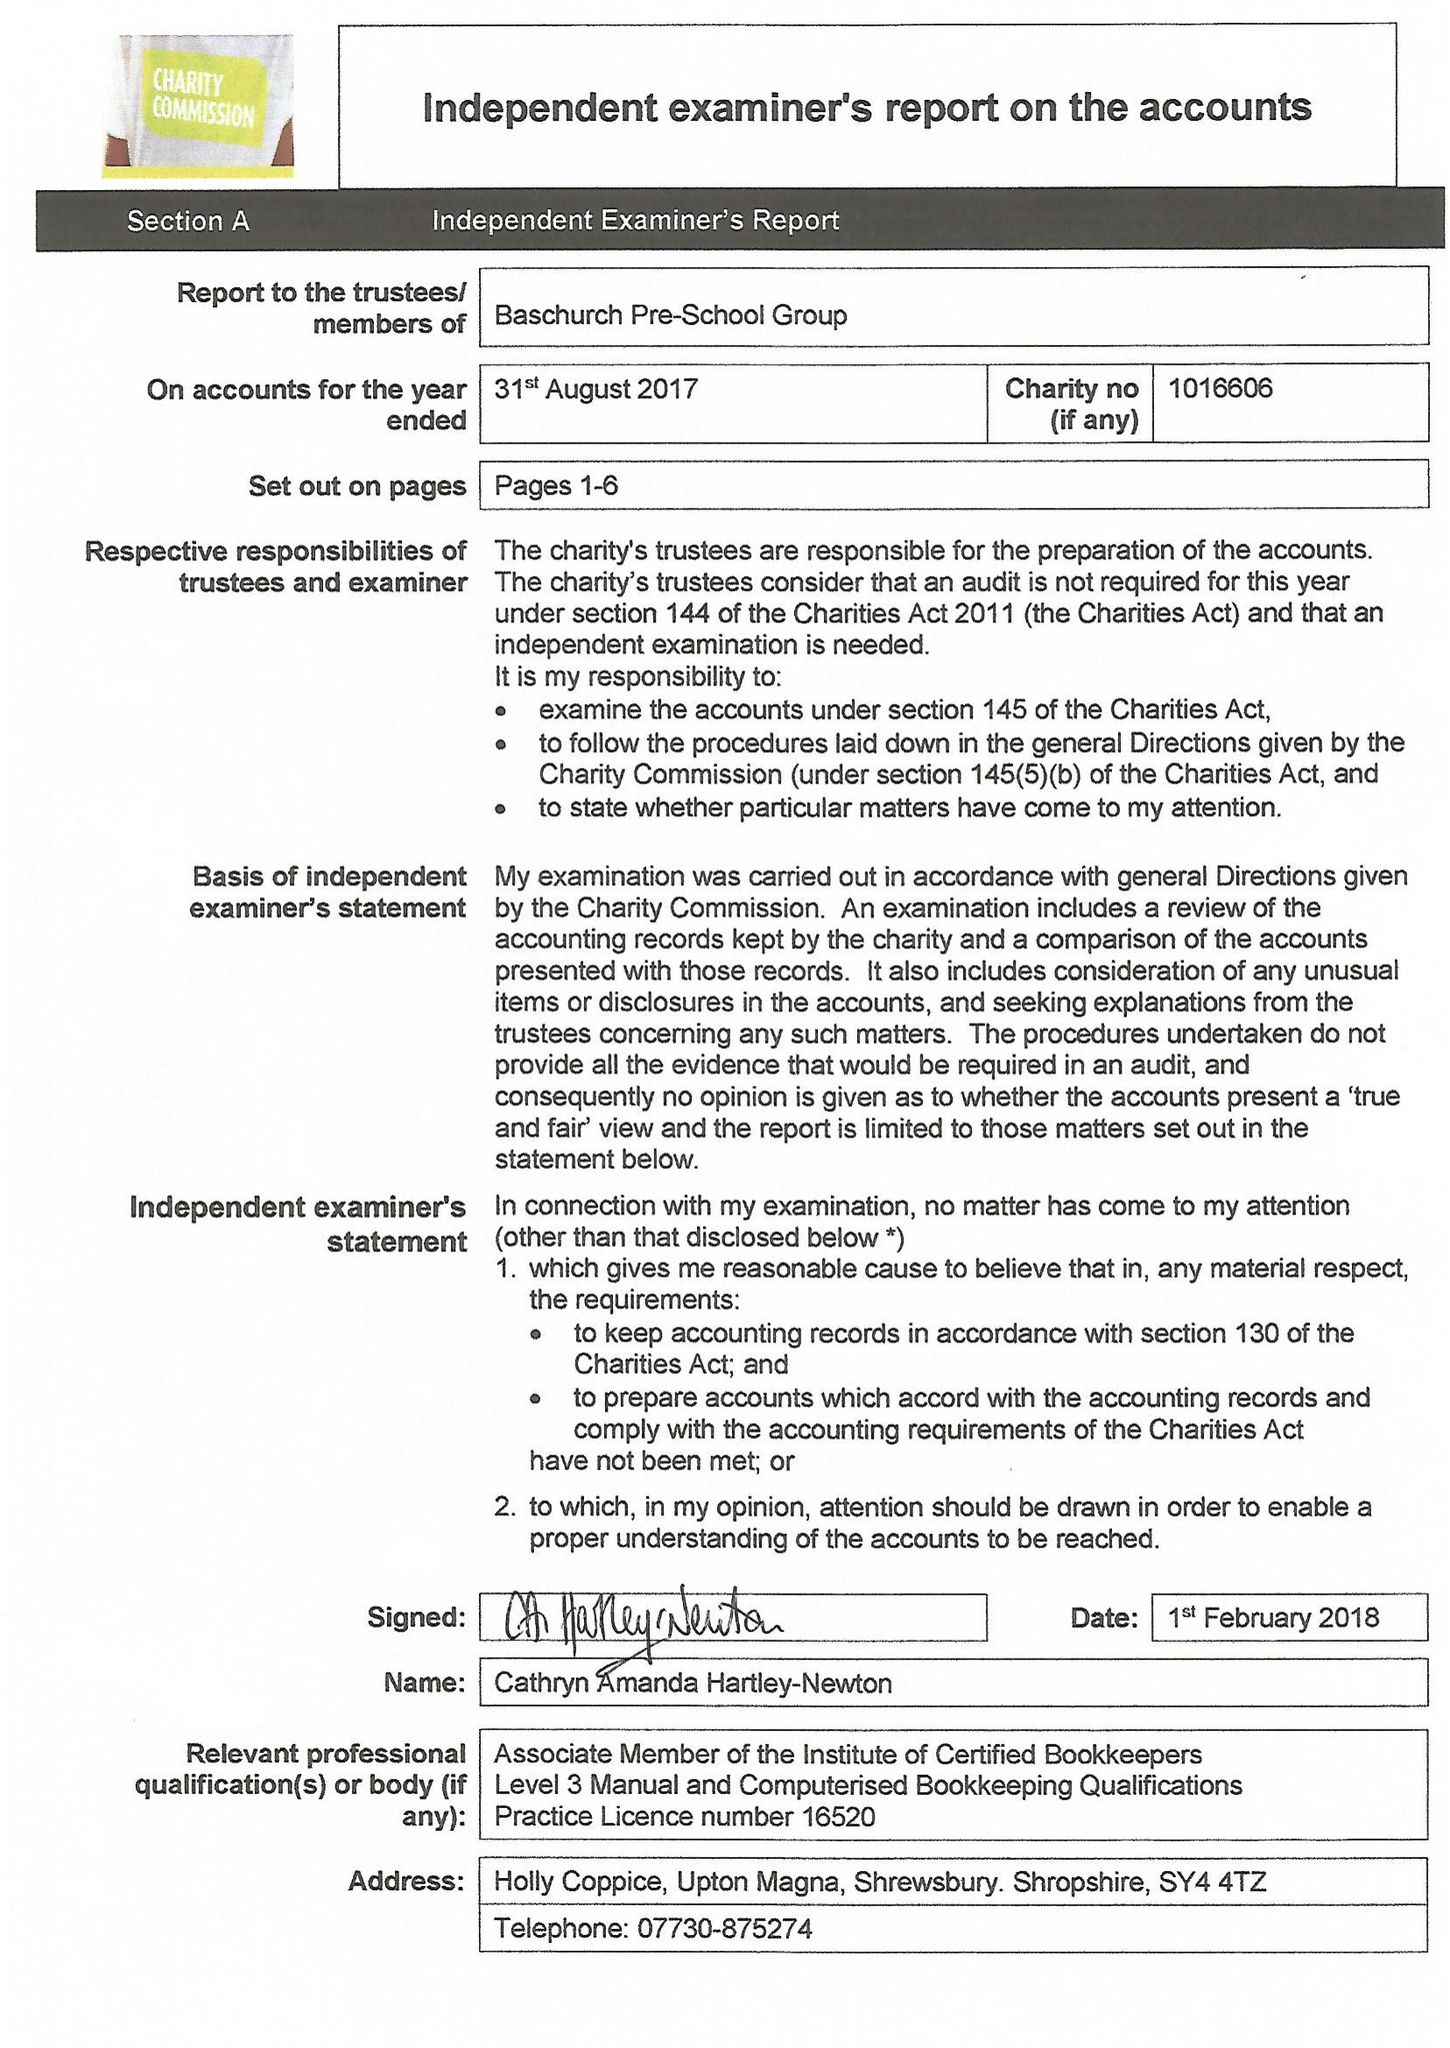What is the value for the address__postcode?
Answer the question using a single word or phrase. SY22 6RL 